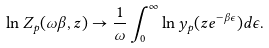<formula> <loc_0><loc_0><loc_500><loc_500>\ln Z _ { p } ( \omega \beta , z ) \to \frac { 1 } { \omega } \int _ { 0 } ^ { \infty } \ln y _ { p } ( z e ^ { - \beta \epsilon } ) d \epsilon .</formula> 